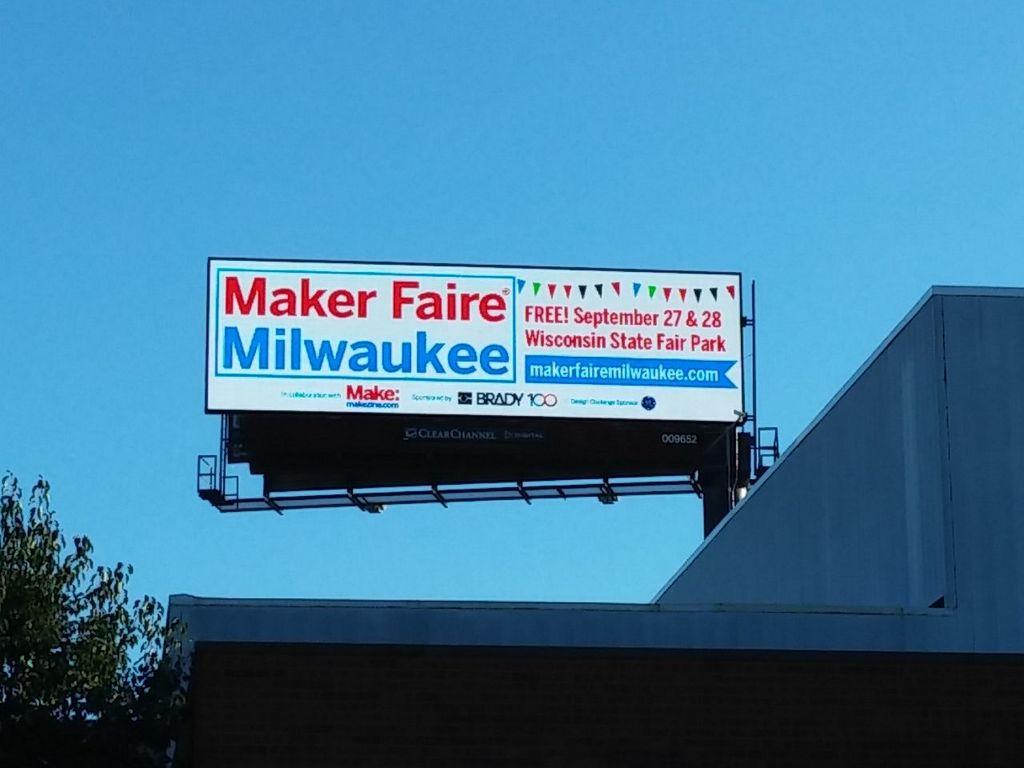What days are free?
Offer a very short reply. September 27 & 28. 